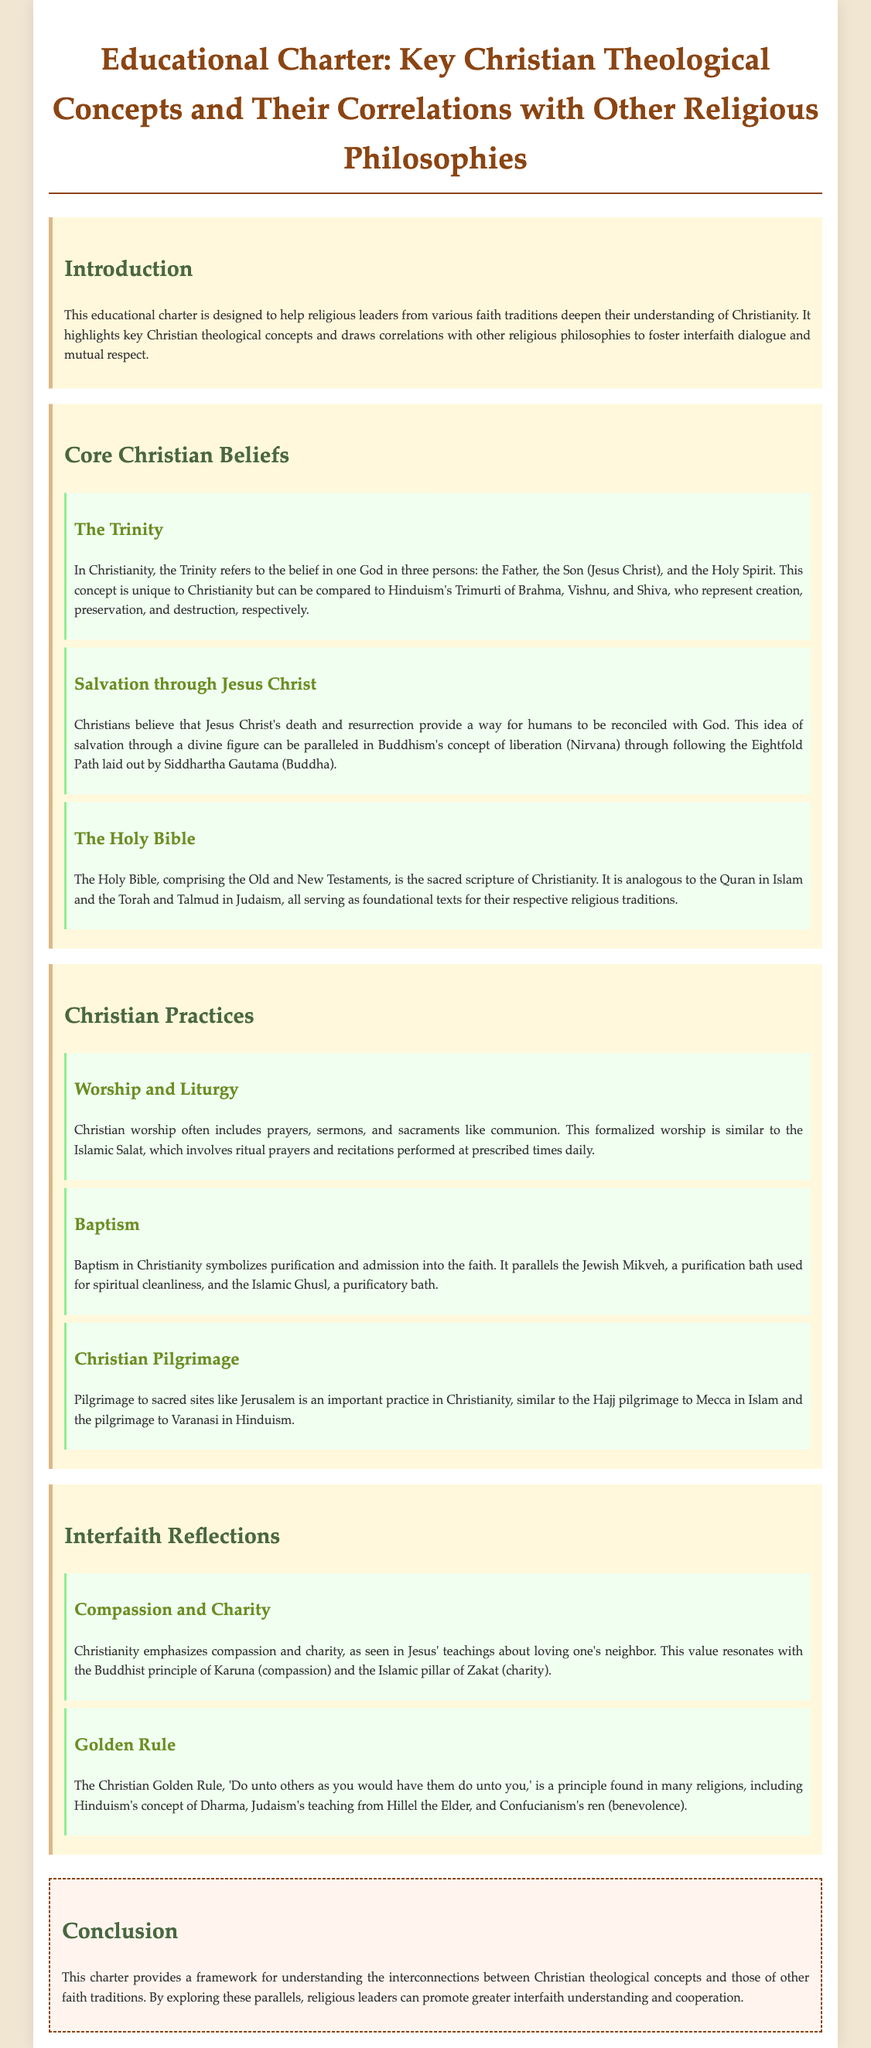What is the title of the document? The title is the primary heading at the top of the document, which summarizes its content.
Answer: Educational Charter: Key Christian Theological Concepts and Their Correlations with Other Religious Philosophies Who is the intended audience for this charter? The intended audience is mentioned in the introduction section of the document, reflecting who this educational material is designed for.
Answer: Religious leaders from various faith traditions What are the three persons of the Trinity? The document provides a specific description of the Trinity, detailing its three components.
Answer: The Father, the Son (Jesus Christ), and the Holy Spirit Which Christian practice symbolizes purification? The document highlights specific practices in Christianity, and one is explicitly related to the concept of purification.
Answer: Baptism What does the Christian Golden Rule state? The document outlines various ethical teachings, including a specific reference to a principle known as the Golden Rule.
Answer: Do unto others as you would have them do unto you How is salvation achieved according to Christian belief? The document explains the concept of salvation in Christianity, emphasizing the importance of a specific figure.
Answer: Through Jesus Christ's death and resurrection What sacred text is analogous to the Holy Bible in Islam? The document compares Christian texts with those in other faith traditions, specifically mentioning a key Islamic text.
Answer: The Quran What is a Christian pilgrimage site mentioned in the document? The document lists important practices in Christianity, including a specific site for pilgrimage.
Answer: Jerusalem What value resonates with both Christianity and Buddhism? The document mentions a principle shared between these two religions, focusing on compassion.
Answer: Compassion and charity 